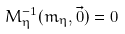Convert formula to latex. <formula><loc_0><loc_0><loc_500><loc_500>M _ { \eta } ^ { - 1 } ( m _ { \eta } , \vec { 0 } ) = 0</formula> 